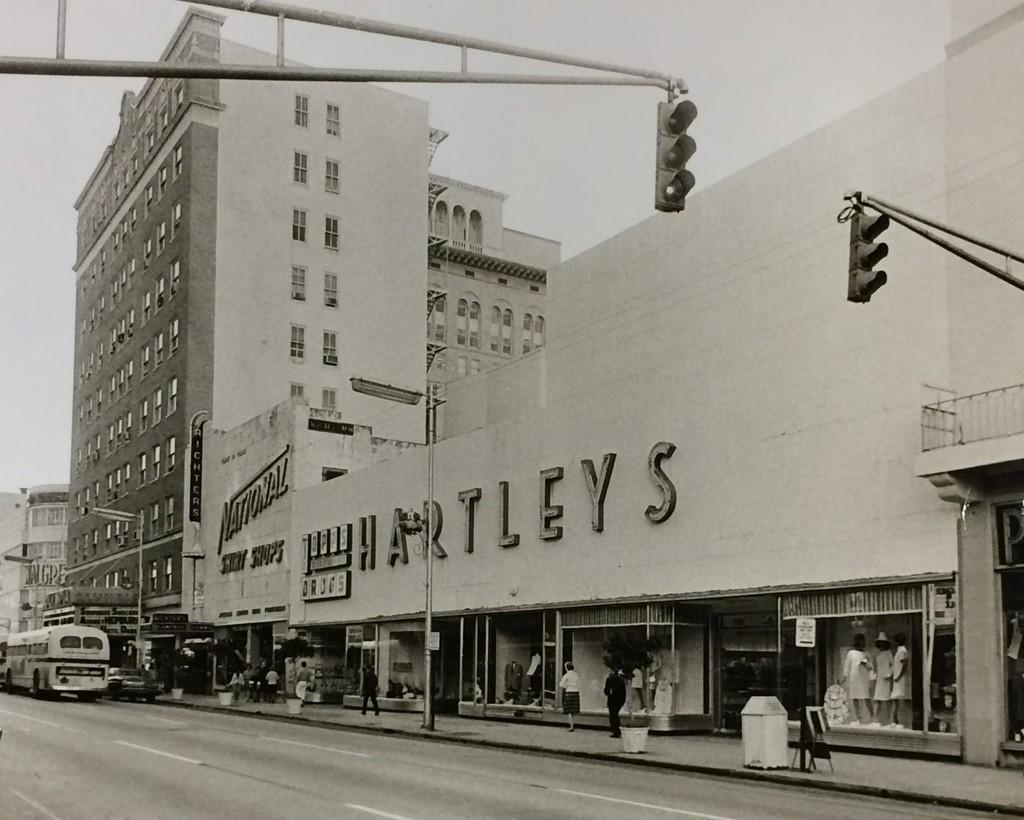Describe this image in one or two sentences. In this image there is a road, On the road there is a bus, traffic light, street light and a pot. And at the sidewalk there are persons walking. At the right side there is a building and a sky. 